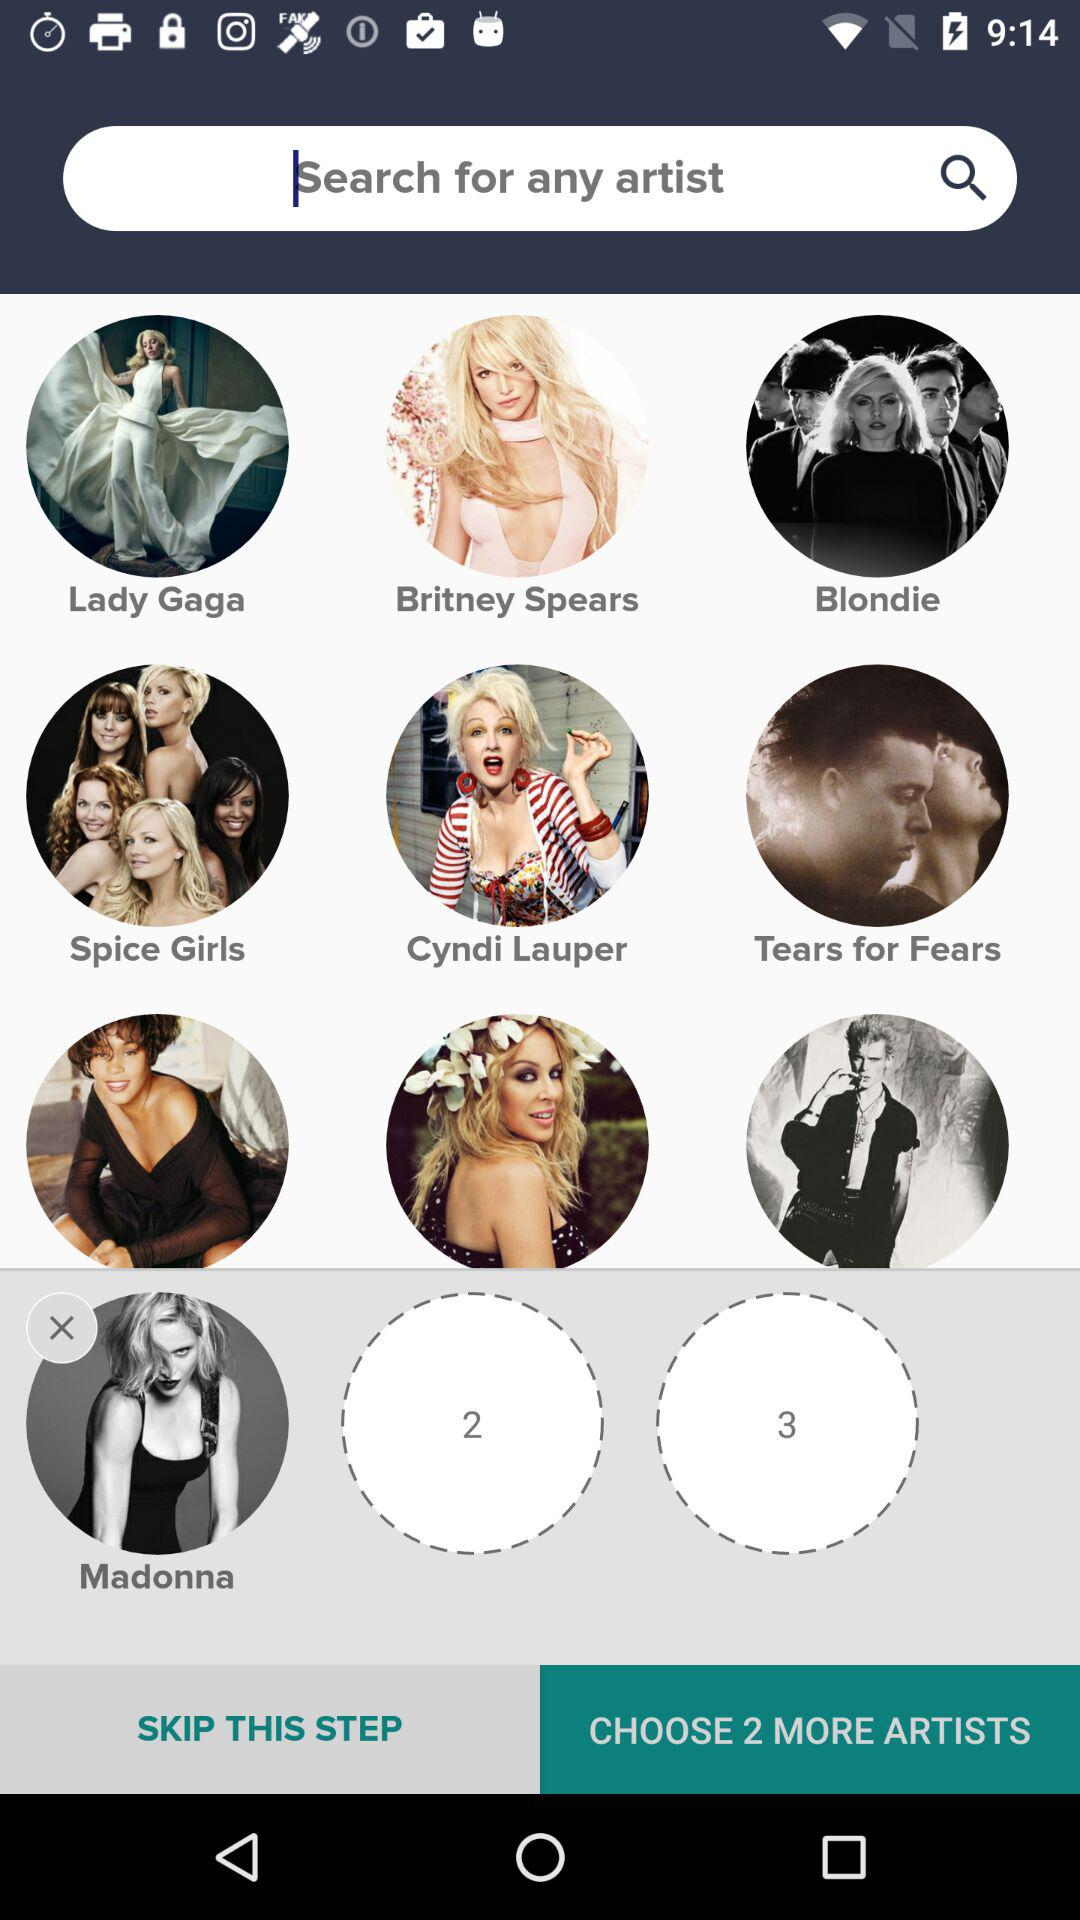Who is the selected artist? The selected artist is Madonna. 